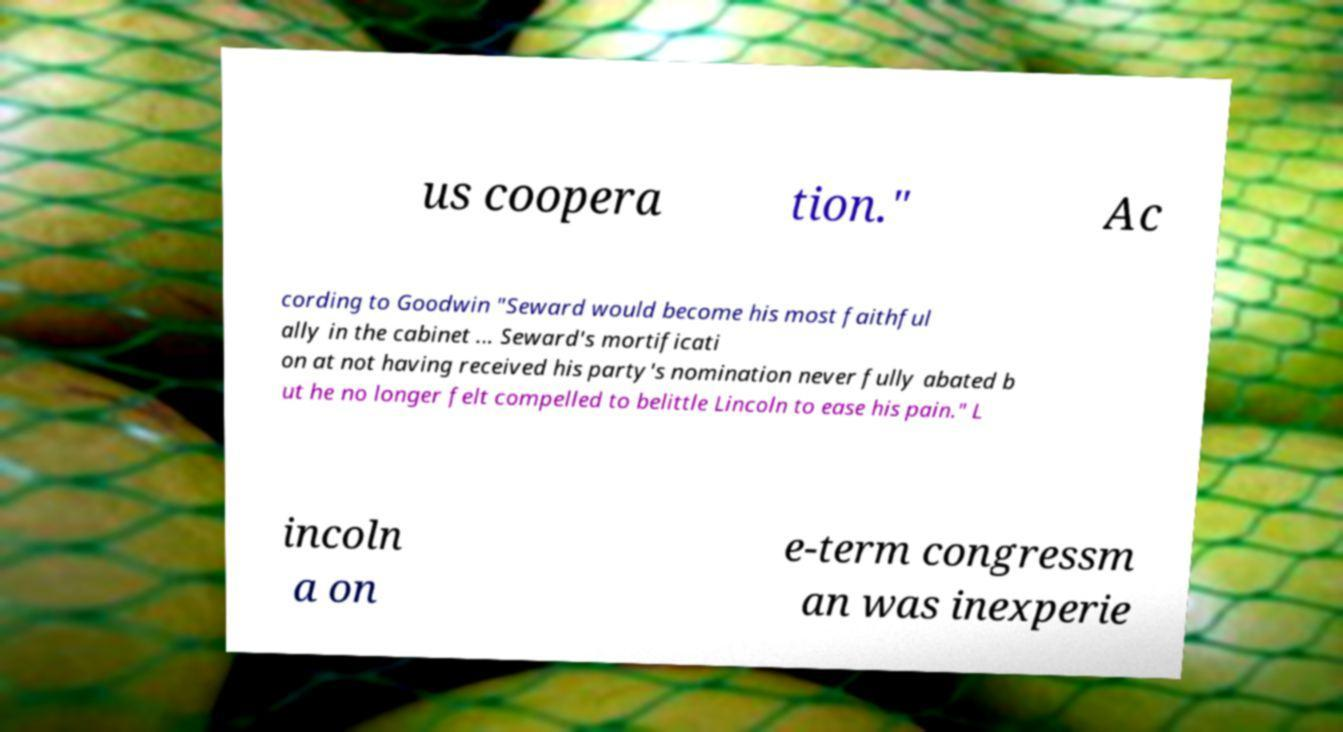Can you accurately transcribe the text from the provided image for me? us coopera tion." Ac cording to Goodwin "Seward would become his most faithful ally in the cabinet ... Seward's mortificati on at not having received his party's nomination never fully abated b ut he no longer felt compelled to belittle Lincoln to ease his pain." L incoln a on e-term congressm an was inexperie 